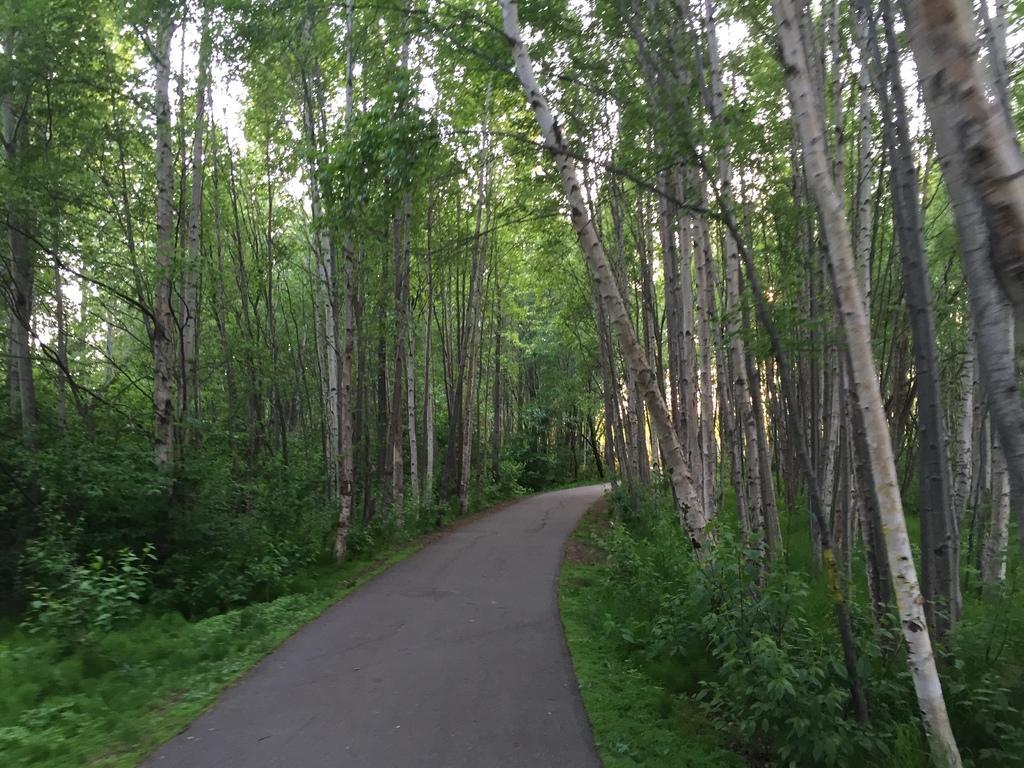Please provide a concise description of this image. In the center of the image there is a road. To the both sides of the image there are trees. At the bottom of the image there is grass. 